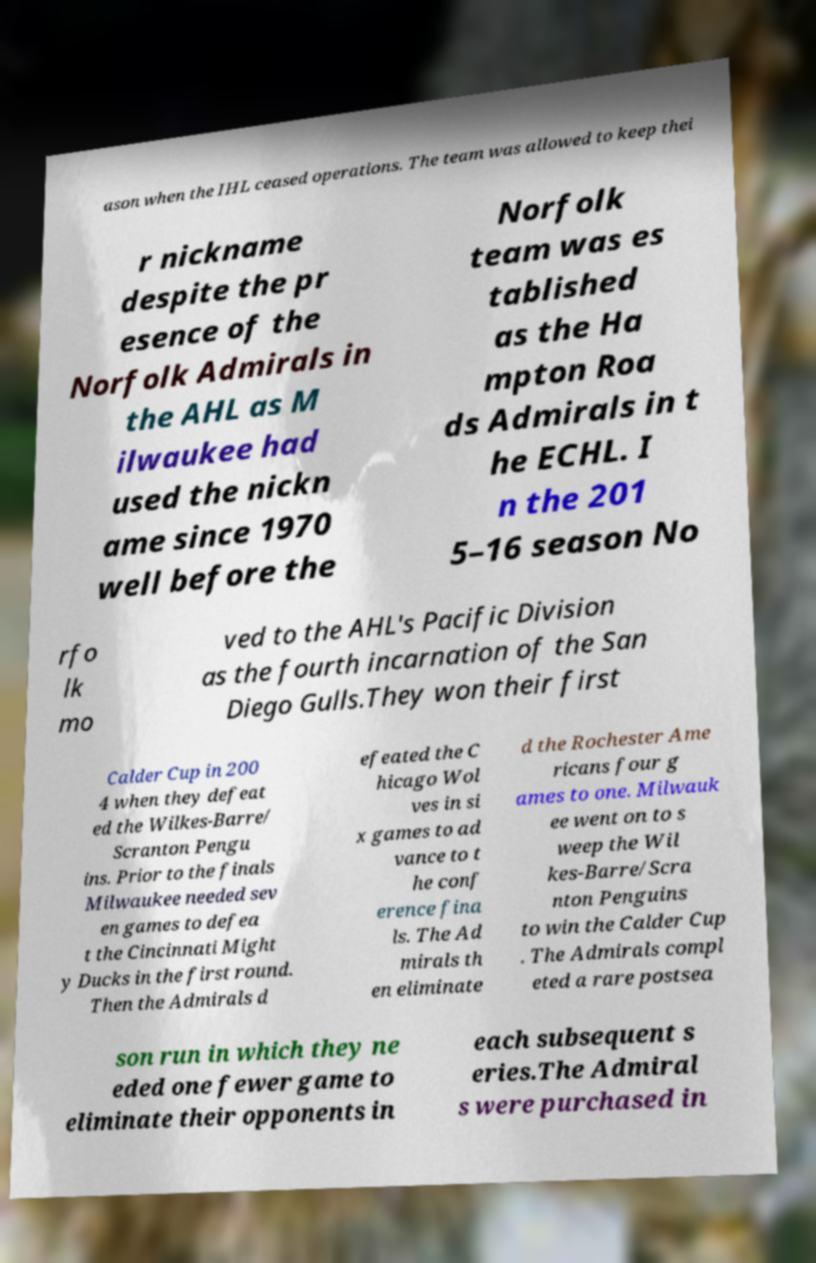Could you assist in decoding the text presented in this image and type it out clearly? ason when the IHL ceased operations. The team was allowed to keep thei r nickname despite the pr esence of the Norfolk Admirals in the AHL as M ilwaukee had used the nickn ame since 1970 well before the Norfolk team was es tablished as the Ha mpton Roa ds Admirals in t he ECHL. I n the 201 5–16 season No rfo lk mo ved to the AHL's Pacific Division as the fourth incarnation of the San Diego Gulls.They won their first Calder Cup in 200 4 when they defeat ed the Wilkes-Barre/ Scranton Pengu ins. Prior to the finals Milwaukee needed sev en games to defea t the Cincinnati Might y Ducks in the first round. Then the Admirals d efeated the C hicago Wol ves in si x games to ad vance to t he conf erence fina ls. The Ad mirals th en eliminate d the Rochester Ame ricans four g ames to one. Milwauk ee went on to s weep the Wil kes-Barre/Scra nton Penguins to win the Calder Cup . The Admirals compl eted a rare postsea son run in which they ne eded one fewer game to eliminate their opponents in each subsequent s eries.The Admiral s were purchased in 